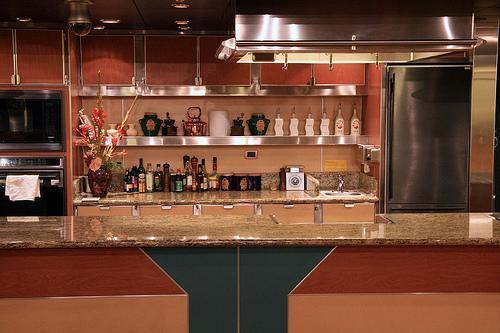How many stoves are shown?
Give a very brief answer. 2. 